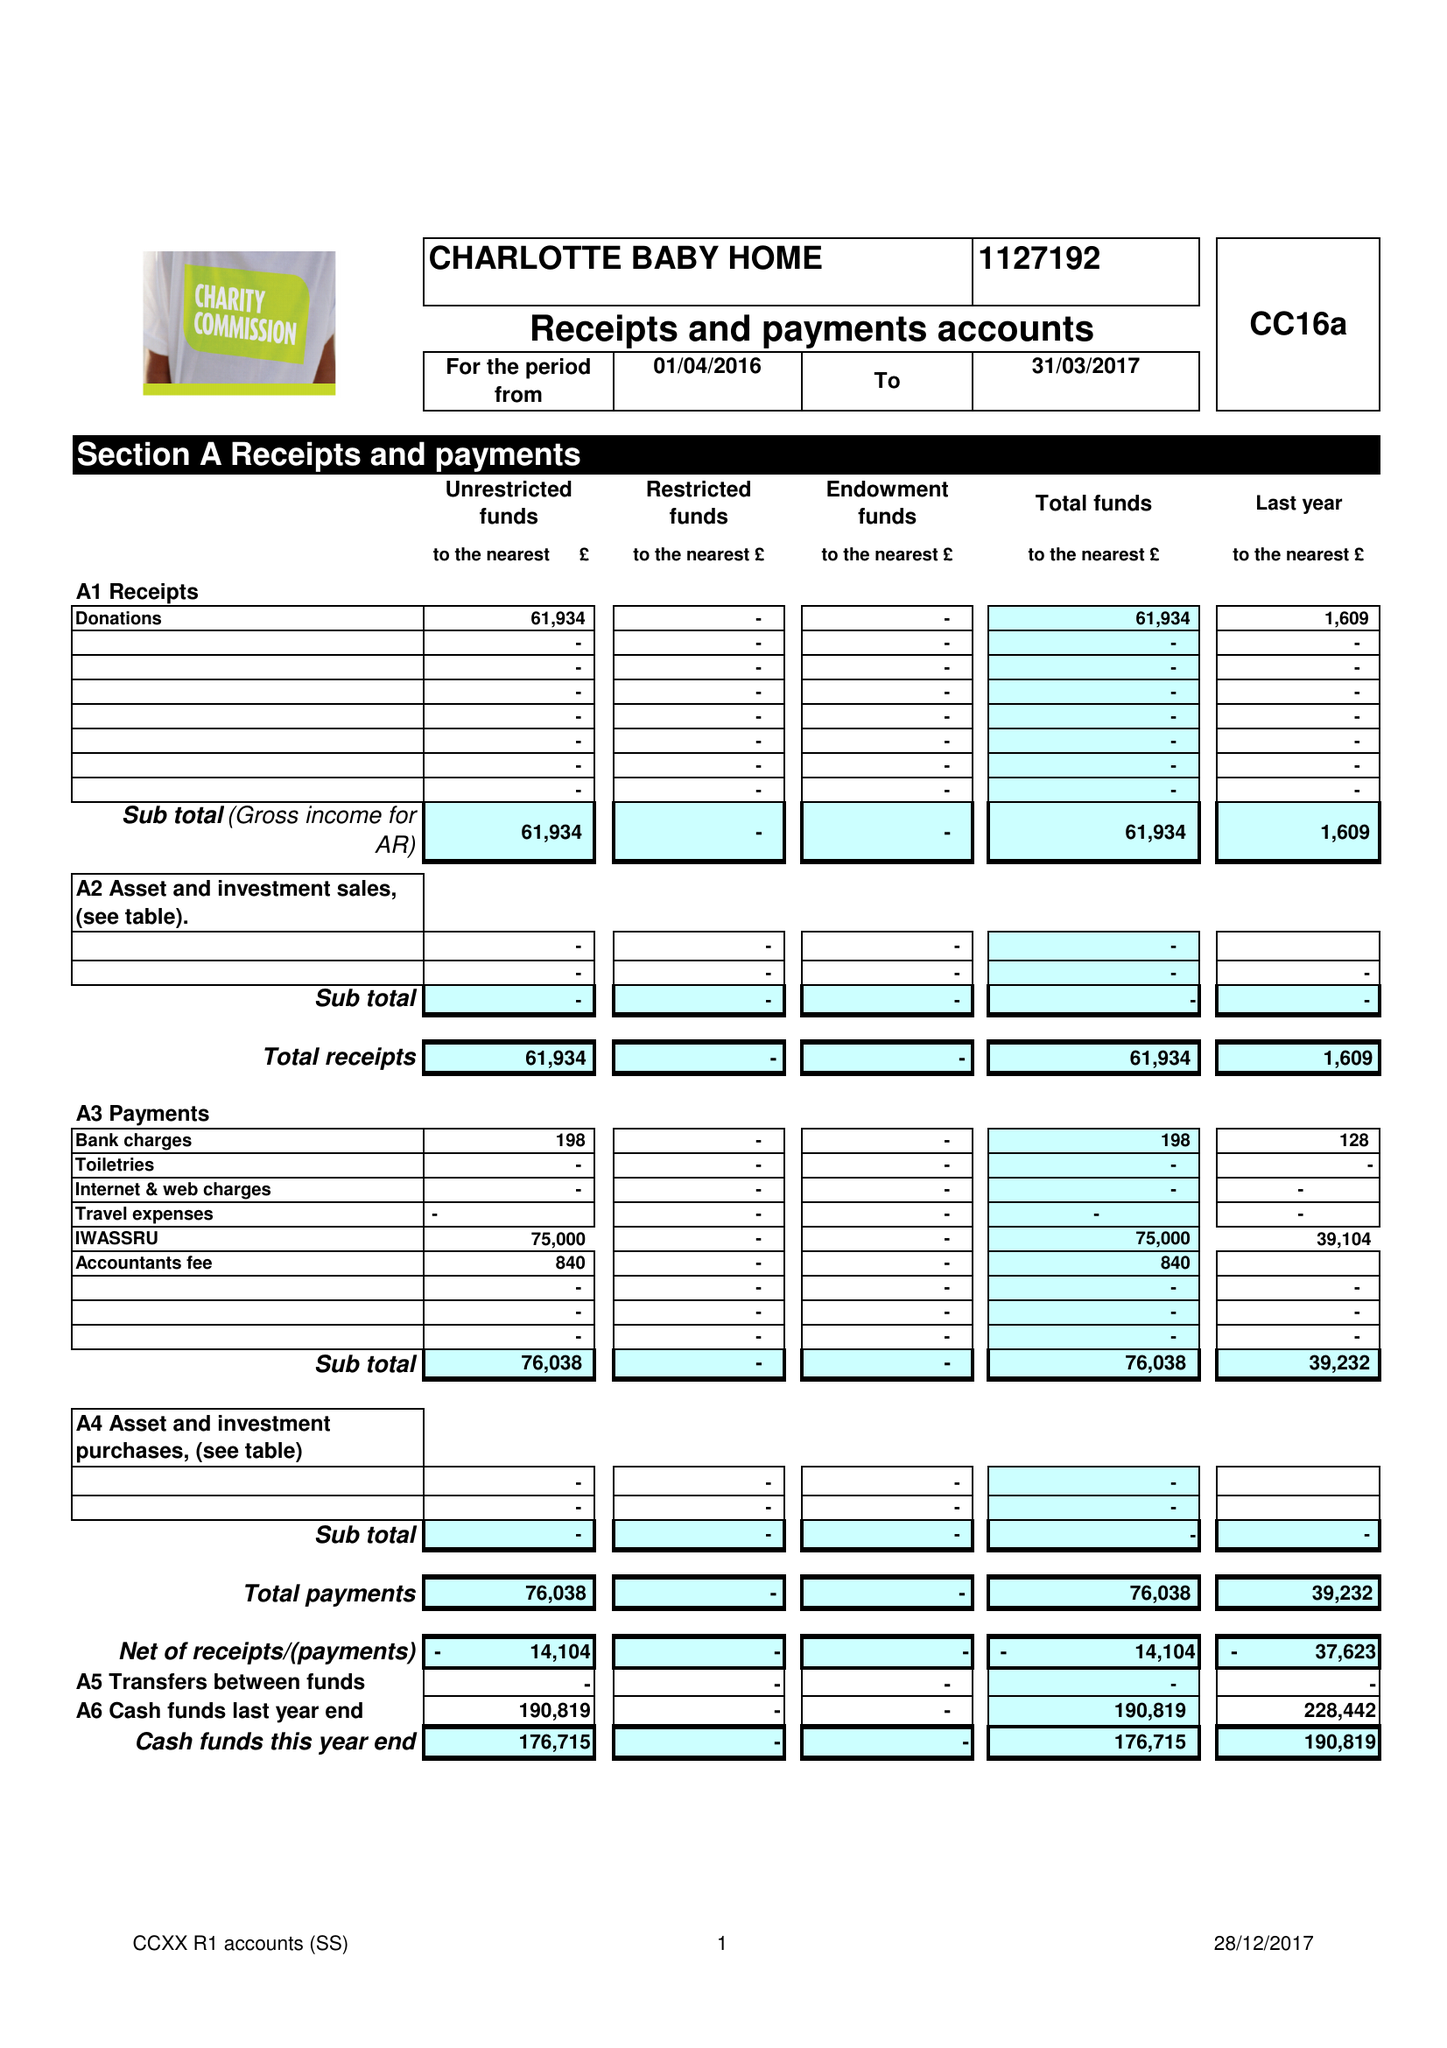What is the value for the address__street_line?
Answer the question using a single word or phrase. 9A IRONMONGER LANE 